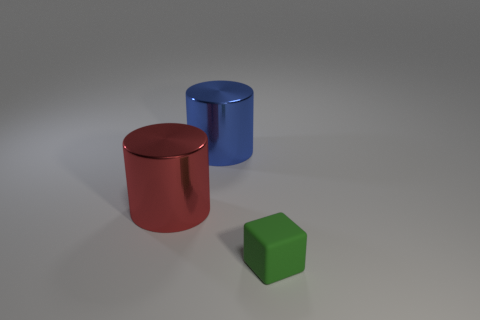Add 2 brown metallic balls. How many objects exist? 5 Subtract all blue cylinders. How many cylinders are left? 1 Subtract all blocks. How many objects are left? 2 Add 1 large red shiny cylinders. How many large red shiny cylinders are left? 2 Add 1 green rubber cubes. How many green rubber cubes exist? 2 Subtract 0 green cylinders. How many objects are left? 3 Subtract all brown blocks. Subtract all green cylinders. How many blocks are left? 1 Subtract all green things. Subtract all big shiny cylinders. How many objects are left? 0 